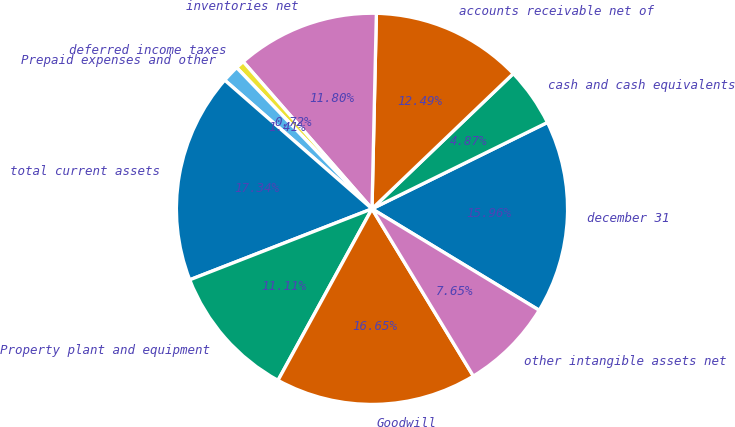Convert chart. <chart><loc_0><loc_0><loc_500><loc_500><pie_chart><fcel>december 31<fcel>cash and cash equivalents<fcel>accounts receivable net of<fcel>inventories net<fcel>deferred income taxes<fcel>Prepaid expenses and other<fcel>total current assets<fcel>Property plant and equipment<fcel>Goodwill<fcel>other intangible assets net<nl><fcel>15.96%<fcel>4.87%<fcel>12.49%<fcel>11.8%<fcel>0.72%<fcel>1.41%<fcel>17.34%<fcel>11.11%<fcel>16.65%<fcel>7.65%<nl></chart> 